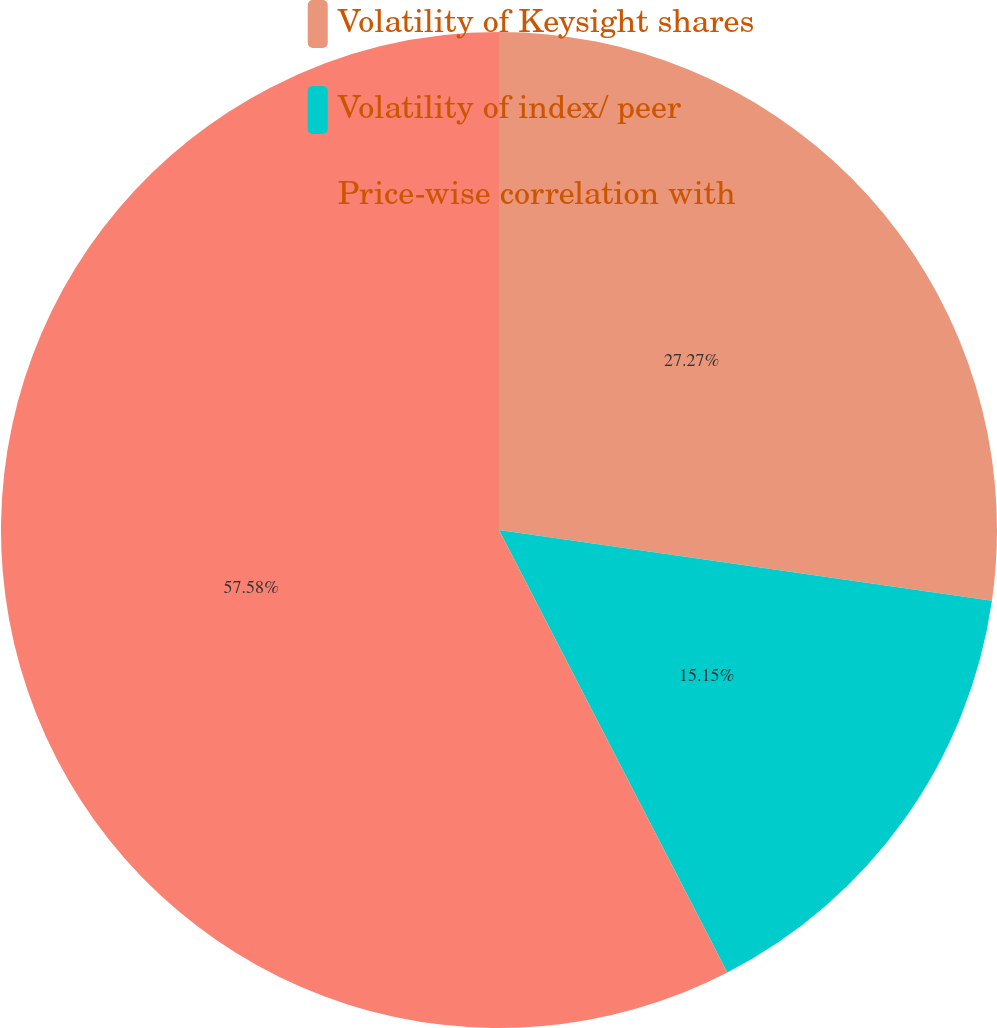Convert chart to OTSL. <chart><loc_0><loc_0><loc_500><loc_500><pie_chart><fcel>Volatility of Keysight shares<fcel>Volatility of index/ peer<fcel>Price-wise correlation with<nl><fcel>27.27%<fcel>15.15%<fcel>57.58%<nl></chart> 